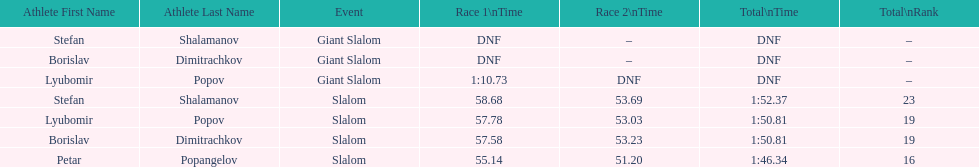What is the rank number of stefan shalamanov in the slalom event 23. 